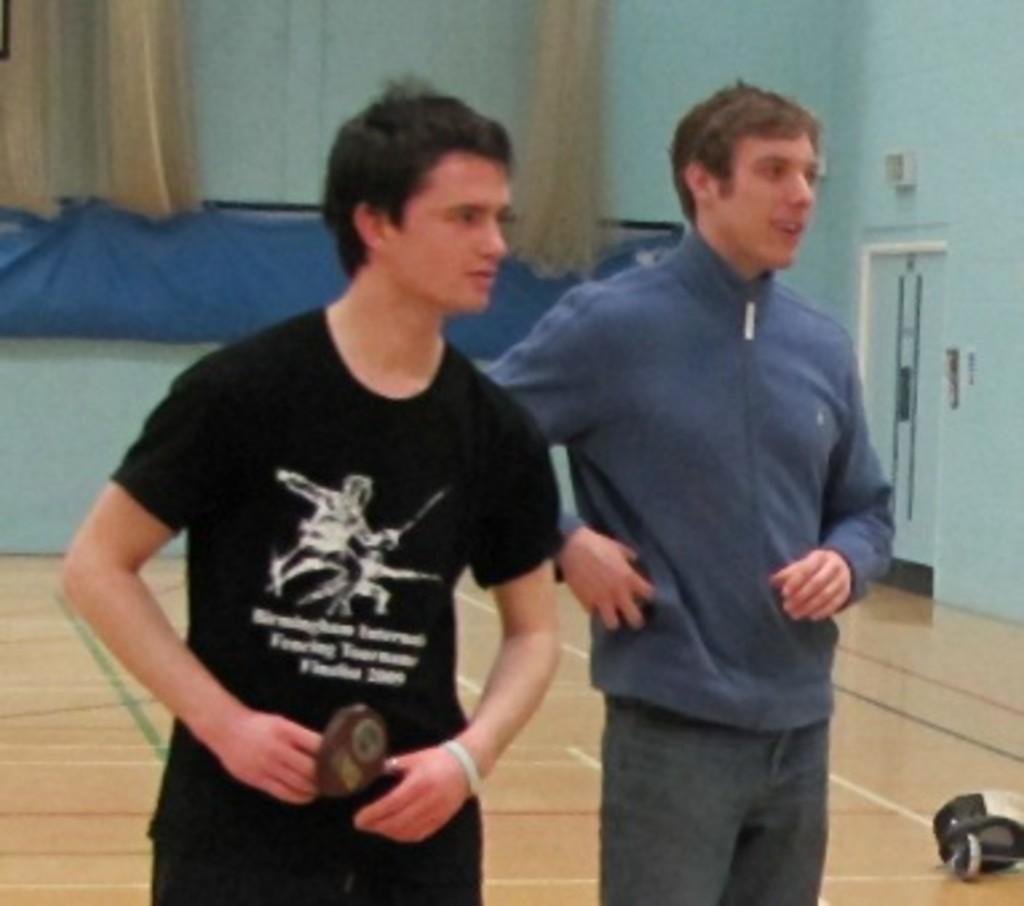Could you give a brief overview of what you see in this image? This image is clicked inside a room. There are curtains at the top. There is a door on the right side. There are two persons standing in the middle. One is wearing blue color dress. Another one is wearing black dress. 